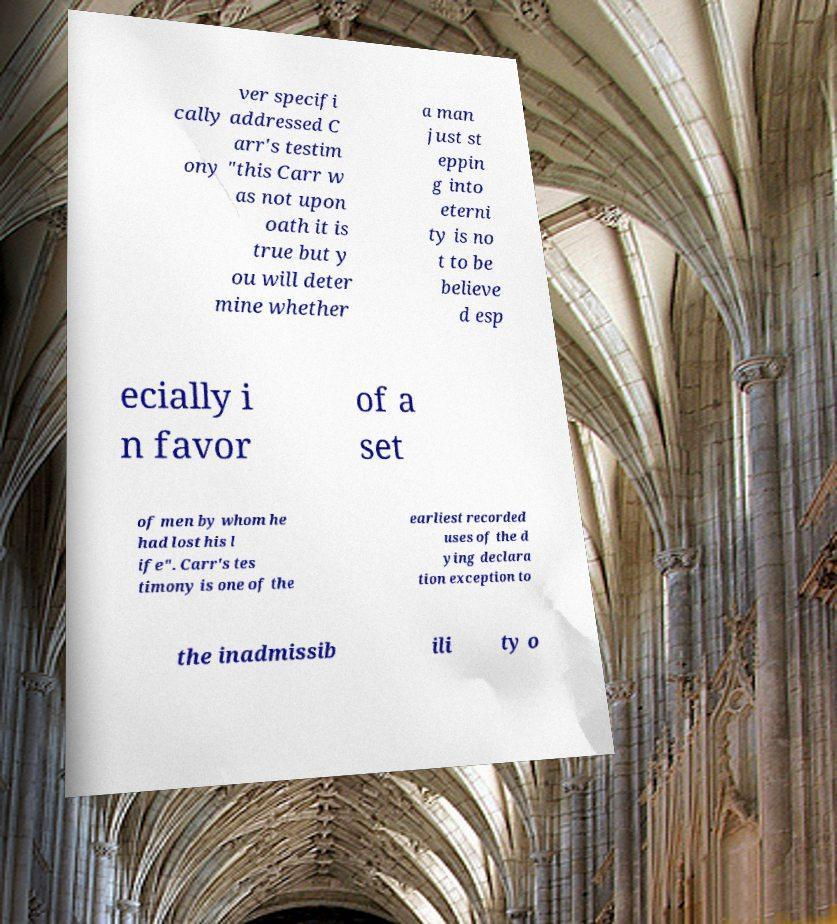I need the written content from this picture converted into text. Can you do that? ver specifi cally addressed C arr's testim ony "this Carr w as not upon oath it is true but y ou will deter mine whether a man just st eppin g into eterni ty is no t to be believe d esp ecially i n favor of a set of men by whom he had lost his l ife". Carr's tes timony is one of the earliest recorded uses of the d ying declara tion exception to the inadmissib ili ty o 